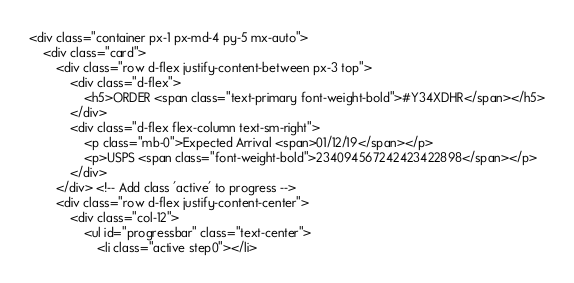Convert code to text. <code><loc_0><loc_0><loc_500><loc_500><_PHP_><div class="container px-1 px-md-4 py-5 mx-auto">
    <div class="card">
        <div class="row d-flex justify-content-between px-3 top">
            <div class="d-flex">
                <h5>ORDER <span class="text-primary font-weight-bold">#Y34XDHR</span></h5>
            </div>
            <div class="d-flex flex-column text-sm-right">
                <p class="mb-0">Expected Arrival <span>01/12/19</span></p>
                <p>USPS <span class="font-weight-bold">234094567242423422898</span></p>
            </div>
        </div> <!-- Add class 'active' to progress -->
        <div class="row d-flex justify-content-center">
            <div class="col-12">
                <ul id="progressbar" class="text-center">
                    <li class="active step0"></li></code> 